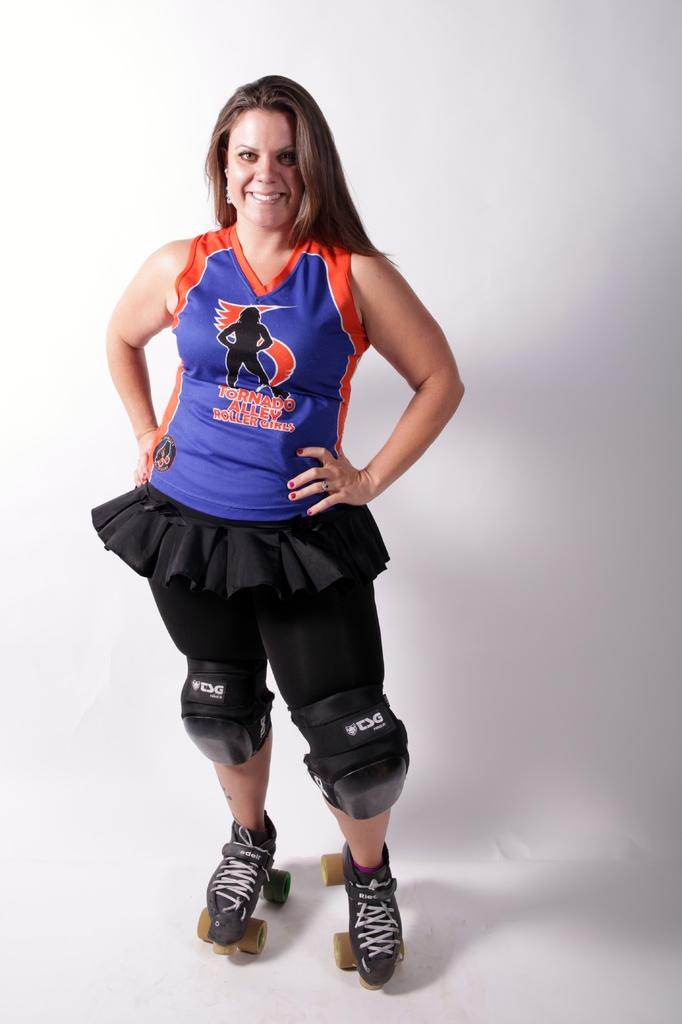Provide a one-sentence caption for the provided image. a woman on sports gear and rollerskates with Tornado alley roller girls on her shirt. 